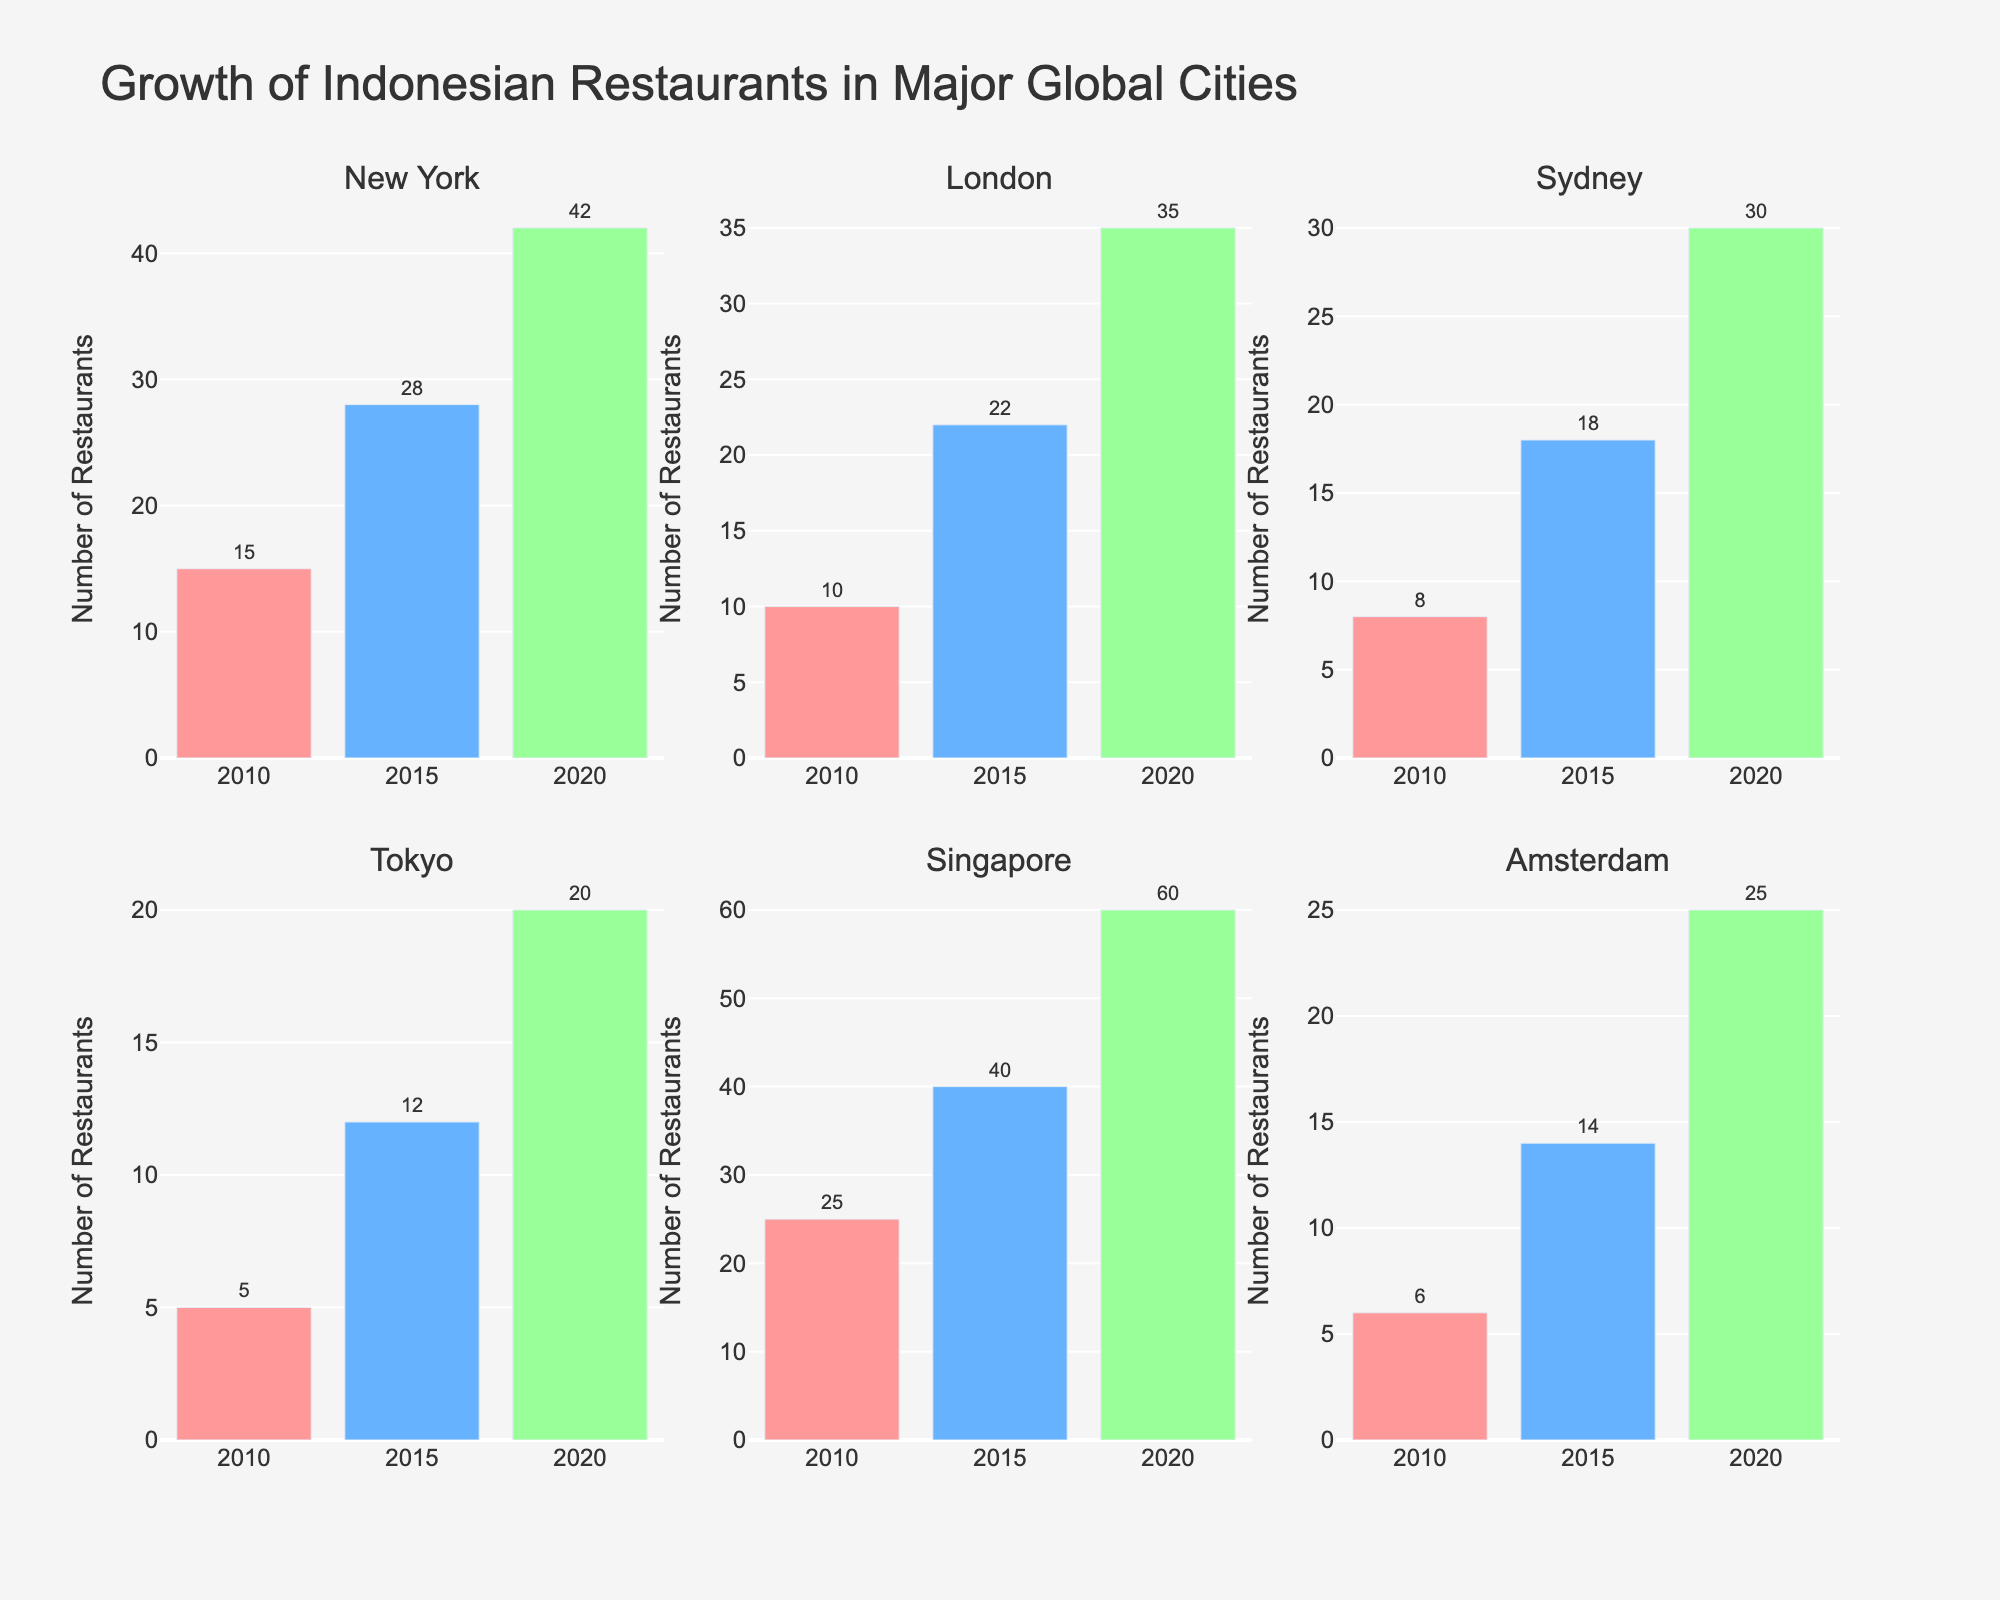What is the overall trend in the number of Indonesian restaurants in New York from 2010 to 2020? The bar heights for New York in 2010, 2015, and 2020 are 15, 28, and 42 respectively which indicates a steady increase over time.
Answer: Increasing How many Indonesian restaurants were there in Singapore in 2015? Referring to the bar for Singapore in 2015, the height is 40, meaning there were 40 Indonesian restaurants in Singapore in that year.
Answer: 40 Which city had the highest number of Indonesian restaurants in 2020? By comparing the tallest bars for each city in 2020, Singapore has the highest with a bar height of 60.
Answer: Singapore Calculate the increase in the number of Indonesian restaurants in Tokyo from 2010 to 2020. The bar heights in Tokyo for 2010 and 2020 are 5 and 20 respectively, so the increase is 20 - 5 = 15.
Answer: 15 Compare the growth of Indonesian restaurants between Sydney and Amsterdam from 2010 to 2020. Which city saw a greater increase? Sydney had 8 restaurants in 2010 and 30 in 2020, an increase of 22. Amsterdam had 6 in 2010 and 25 in 2020, an increase of 19. Comparing these, Sydney had a greater increase of 22 compared to Amsterdam's 19.
Answer: Sydney Which city's number of Indonesian restaurants doubled from 2010 to 2015? Checking each city: New York (28/15 ≈ 1.87), London (22/10 = 2.2), Sydney (18/8 = 2.25), Tokyo (12/5 = 2.4), Singapore (40/25 = 1.6), Amsterdam (14/6 ≈ 2.33). The cities where numbers doubled or more are London, Sydney, Tokyo, and Amsterdam.
Answer: London, Sydney, Tokyo, Amsterdam What was the total number of Indonesian restaurants in all cities combined in 2020? Summing the bars for all cities in 2020: (New York: 42) + (London: 35) + (Sydney: 30) + (Tokyo: 20) + (Singapore: 60) + (Amsterdam: 25) = 212.
Answer: 212 Which city showed the smallest growth in the number of Indonesian restaurants between 2010 and 2020? Calculating growth: New York (42-15=27), London (35-10=25), Sydney (30-8=22), Tokyo (20-5=15), Singapore (60-25=35), Amsterdam (25-6=19). Tokyo has the smallest growth with an increase of 15 restaurants.
Answer: Tokyo 